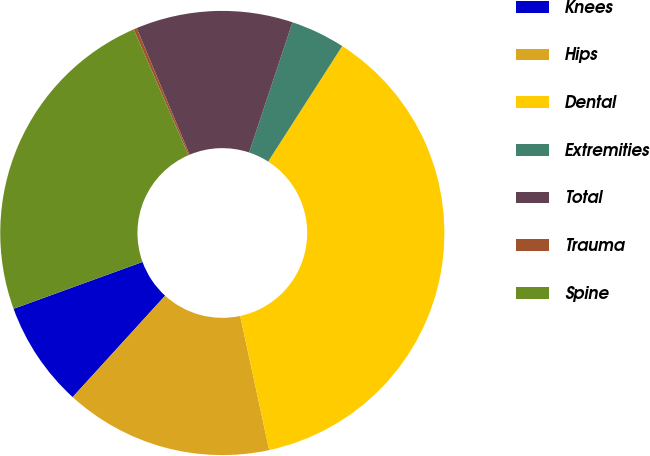Convert chart to OTSL. <chart><loc_0><loc_0><loc_500><loc_500><pie_chart><fcel>Knees<fcel>Hips<fcel>Dental<fcel>Extremities<fcel>Total<fcel>Trauma<fcel>Spine<nl><fcel>7.69%<fcel>15.15%<fcel>37.54%<fcel>3.96%<fcel>11.42%<fcel>0.23%<fcel>24.01%<nl></chart> 